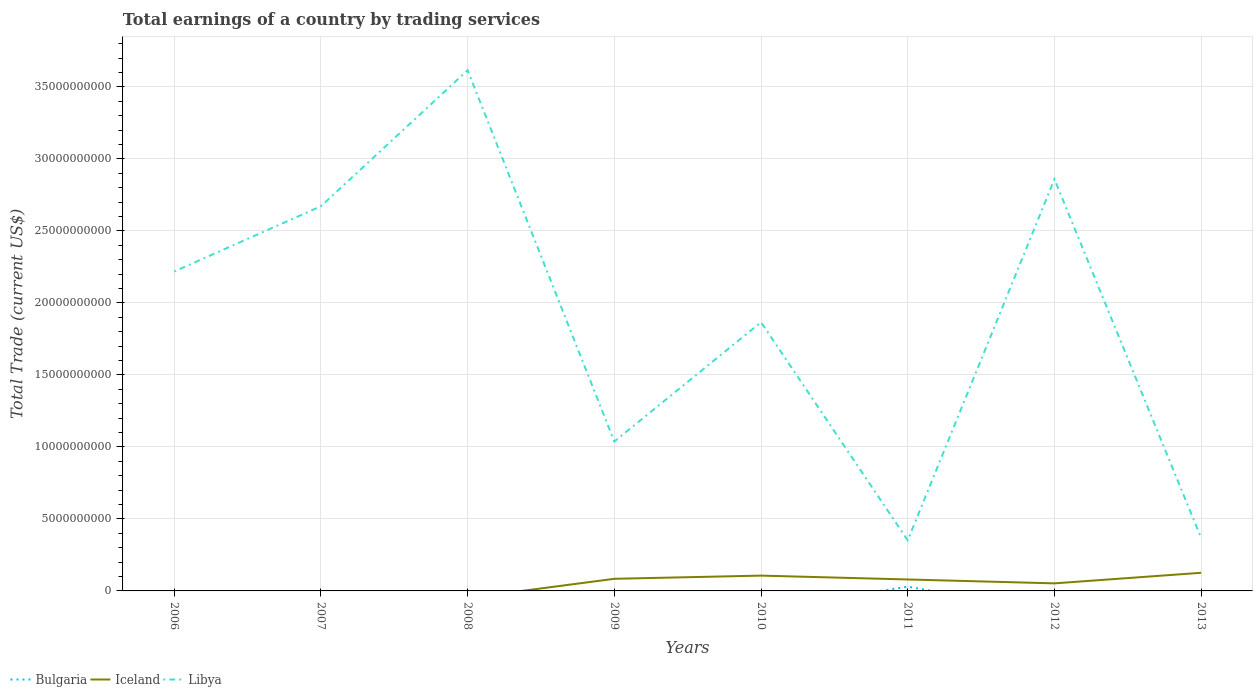How many different coloured lines are there?
Your answer should be compact. 3. What is the total total earnings in Iceland in the graph?
Provide a succinct answer. -7.34e+08. What is the difference between the highest and the second highest total earnings in Iceland?
Ensure brevity in your answer.  1.26e+09. What is the difference between the highest and the lowest total earnings in Iceland?
Your answer should be compact. 4. Is the total earnings in Libya strictly greater than the total earnings in Iceland over the years?
Offer a very short reply. No. How many lines are there?
Ensure brevity in your answer.  3. How many years are there in the graph?
Keep it short and to the point. 8. What is the difference between two consecutive major ticks on the Y-axis?
Provide a succinct answer. 5.00e+09. Are the values on the major ticks of Y-axis written in scientific E-notation?
Offer a terse response. No. How are the legend labels stacked?
Offer a very short reply. Horizontal. What is the title of the graph?
Provide a succinct answer. Total earnings of a country by trading services. What is the label or title of the Y-axis?
Provide a short and direct response. Total Trade (current US$). What is the Total Trade (current US$) in Iceland in 2006?
Provide a succinct answer. 0. What is the Total Trade (current US$) of Libya in 2006?
Offer a very short reply. 2.22e+1. What is the Total Trade (current US$) in Bulgaria in 2007?
Provide a short and direct response. 0. What is the Total Trade (current US$) of Iceland in 2007?
Keep it short and to the point. 0. What is the Total Trade (current US$) of Libya in 2007?
Give a very brief answer. 2.67e+1. What is the Total Trade (current US$) of Bulgaria in 2008?
Your answer should be compact. 0. What is the Total Trade (current US$) of Iceland in 2008?
Make the answer very short. 0. What is the Total Trade (current US$) of Libya in 2008?
Offer a very short reply. 3.62e+1. What is the Total Trade (current US$) in Iceland in 2009?
Keep it short and to the point. 8.42e+08. What is the Total Trade (current US$) of Libya in 2009?
Offer a terse response. 1.04e+1. What is the Total Trade (current US$) in Iceland in 2010?
Offer a terse response. 1.06e+09. What is the Total Trade (current US$) of Libya in 2010?
Your answer should be very brief. 1.87e+1. What is the Total Trade (current US$) of Bulgaria in 2011?
Your response must be concise. 2.94e+08. What is the Total Trade (current US$) in Iceland in 2011?
Keep it short and to the point. 7.95e+08. What is the Total Trade (current US$) in Libya in 2011?
Your answer should be compact. 3.51e+09. What is the Total Trade (current US$) in Iceland in 2012?
Offer a very short reply. 5.25e+08. What is the Total Trade (current US$) of Libya in 2012?
Keep it short and to the point. 2.86e+1. What is the Total Trade (current US$) in Bulgaria in 2013?
Offer a very short reply. 0. What is the Total Trade (current US$) in Iceland in 2013?
Make the answer very short. 1.26e+09. What is the Total Trade (current US$) in Libya in 2013?
Make the answer very short. 3.68e+09. Across all years, what is the maximum Total Trade (current US$) in Bulgaria?
Your answer should be very brief. 2.94e+08. Across all years, what is the maximum Total Trade (current US$) in Iceland?
Offer a very short reply. 1.26e+09. Across all years, what is the maximum Total Trade (current US$) in Libya?
Provide a succinct answer. 3.62e+1. Across all years, what is the minimum Total Trade (current US$) of Iceland?
Offer a terse response. 0. Across all years, what is the minimum Total Trade (current US$) of Libya?
Make the answer very short. 3.51e+09. What is the total Total Trade (current US$) of Bulgaria in the graph?
Ensure brevity in your answer.  2.94e+08. What is the total Total Trade (current US$) in Iceland in the graph?
Provide a succinct answer. 4.48e+09. What is the total Total Trade (current US$) of Libya in the graph?
Offer a terse response. 1.50e+11. What is the difference between the Total Trade (current US$) in Libya in 2006 and that in 2007?
Make the answer very short. -4.53e+09. What is the difference between the Total Trade (current US$) of Libya in 2006 and that in 2008?
Ensure brevity in your answer.  -1.40e+1. What is the difference between the Total Trade (current US$) of Libya in 2006 and that in 2009?
Keep it short and to the point. 1.18e+1. What is the difference between the Total Trade (current US$) of Libya in 2006 and that in 2010?
Provide a short and direct response. 3.52e+09. What is the difference between the Total Trade (current US$) in Libya in 2006 and that in 2011?
Offer a very short reply. 1.87e+1. What is the difference between the Total Trade (current US$) in Libya in 2006 and that in 2012?
Your answer should be compact. -6.41e+09. What is the difference between the Total Trade (current US$) in Libya in 2006 and that in 2013?
Provide a succinct answer. 1.85e+1. What is the difference between the Total Trade (current US$) in Libya in 2007 and that in 2008?
Your answer should be compact. -9.44e+09. What is the difference between the Total Trade (current US$) of Libya in 2007 and that in 2009?
Keep it short and to the point. 1.63e+1. What is the difference between the Total Trade (current US$) in Libya in 2007 and that in 2010?
Provide a succinct answer. 8.05e+09. What is the difference between the Total Trade (current US$) of Libya in 2007 and that in 2011?
Make the answer very short. 2.32e+1. What is the difference between the Total Trade (current US$) of Libya in 2007 and that in 2012?
Provide a short and direct response. -1.88e+09. What is the difference between the Total Trade (current US$) in Libya in 2007 and that in 2013?
Ensure brevity in your answer.  2.30e+1. What is the difference between the Total Trade (current US$) in Libya in 2008 and that in 2009?
Provide a succinct answer. 2.58e+1. What is the difference between the Total Trade (current US$) of Libya in 2008 and that in 2010?
Your answer should be very brief. 1.75e+1. What is the difference between the Total Trade (current US$) of Libya in 2008 and that in 2011?
Your response must be concise. 3.26e+1. What is the difference between the Total Trade (current US$) in Libya in 2008 and that in 2012?
Your answer should be compact. 7.56e+09. What is the difference between the Total Trade (current US$) of Libya in 2008 and that in 2013?
Keep it short and to the point. 3.25e+1. What is the difference between the Total Trade (current US$) in Iceland in 2009 and that in 2010?
Provide a short and direct response. -2.21e+08. What is the difference between the Total Trade (current US$) in Libya in 2009 and that in 2010?
Your answer should be compact. -8.28e+09. What is the difference between the Total Trade (current US$) of Iceland in 2009 and that in 2011?
Provide a short and direct response. 4.66e+07. What is the difference between the Total Trade (current US$) of Libya in 2009 and that in 2011?
Provide a short and direct response. 6.86e+09. What is the difference between the Total Trade (current US$) in Iceland in 2009 and that in 2012?
Offer a very short reply. 3.16e+08. What is the difference between the Total Trade (current US$) in Libya in 2009 and that in 2012?
Offer a terse response. -1.82e+1. What is the difference between the Total Trade (current US$) of Iceland in 2009 and that in 2013?
Keep it short and to the point. -4.17e+08. What is the difference between the Total Trade (current US$) in Libya in 2009 and that in 2013?
Your answer should be very brief. 6.70e+09. What is the difference between the Total Trade (current US$) in Iceland in 2010 and that in 2011?
Provide a succinct answer. 2.68e+08. What is the difference between the Total Trade (current US$) in Libya in 2010 and that in 2011?
Make the answer very short. 1.51e+1. What is the difference between the Total Trade (current US$) in Iceland in 2010 and that in 2012?
Make the answer very short. 5.38e+08. What is the difference between the Total Trade (current US$) of Libya in 2010 and that in 2012?
Offer a very short reply. -9.93e+09. What is the difference between the Total Trade (current US$) in Iceland in 2010 and that in 2013?
Ensure brevity in your answer.  -1.96e+08. What is the difference between the Total Trade (current US$) of Libya in 2010 and that in 2013?
Offer a very short reply. 1.50e+1. What is the difference between the Total Trade (current US$) in Iceland in 2011 and that in 2012?
Ensure brevity in your answer.  2.70e+08. What is the difference between the Total Trade (current US$) in Libya in 2011 and that in 2012?
Your answer should be very brief. -2.51e+1. What is the difference between the Total Trade (current US$) of Iceland in 2011 and that in 2013?
Provide a short and direct response. -4.64e+08. What is the difference between the Total Trade (current US$) of Libya in 2011 and that in 2013?
Your response must be concise. -1.63e+08. What is the difference between the Total Trade (current US$) in Iceland in 2012 and that in 2013?
Your response must be concise. -7.34e+08. What is the difference between the Total Trade (current US$) of Libya in 2012 and that in 2013?
Ensure brevity in your answer.  2.49e+1. What is the difference between the Total Trade (current US$) of Iceland in 2009 and the Total Trade (current US$) of Libya in 2010?
Give a very brief answer. -1.78e+1. What is the difference between the Total Trade (current US$) in Iceland in 2009 and the Total Trade (current US$) in Libya in 2011?
Provide a succinct answer. -2.67e+09. What is the difference between the Total Trade (current US$) of Iceland in 2009 and the Total Trade (current US$) of Libya in 2012?
Your answer should be compact. -2.78e+1. What is the difference between the Total Trade (current US$) in Iceland in 2009 and the Total Trade (current US$) in Libya in 2013?
Give a very brief answer. -2.84e+09. What is the difference between the Total Trade (current US$) of Iceland in 2010 and the Total Trade (current US$) of Libya in 2011?
Your response must be concise. -2.45e+09. What is the difference between the Total Trade (current US$) of Iceland in 2010 and the Total Trade (current US$) of Libya in 2012?
Keep it short and to the point. -2.75e+1. What is the difference between the Total Trade (current US$) in Iceland in 2010 and the Total Trade (current US$) in Libya in 2013?
Provide a succinct answer. -2.61e+09. What is the difference between the Total Trade (current US$) of Bulgaria in 2011 and the Total Trade (current US$) of Iceland in 2012?
Keep it short and to the point. -2.31e+08. What is the difference between the Total Trade (current US$) of Bulgaria in 2011 and the Total Trade (current US$) of Libya in 2012?
Your response must be concise. -2.83e+1. What is the difference between the Total Trade (current US$) of Iceland in 2011 and the Total Trade (current US$) of Libya in 2012?
Give a very brief answer. -2.78e+1. What is the difference between the Total Trade (current US$) of Bulgaria in 2011 and the Total Trade (current US$) of Iceland in 2013?
Your response must be concise. -9.65e+08. What is the difference between the Total Trade (current US$) in Bulgaria in 2011 and the Total Trade (current US$) in Libya in 2013?
Ensure brevity in your answer.  -3.38e+09. What is the difference between the Total Trade (current US$) of Iceland in 2011 and the Total Trade (current US$) of Libya in 2013?
Ensure brevity in your answer.  -2.88e+09. What is the difference between the Total Trade (current US$) of Iceland in 2012 and the Total Trade (current US$) of Libya in 2013?
Your answer should be very brief. -3.15e+09. What is the average Total Trade (current US$) of Bulgaria per year?
Offer a terse response. 3.67e+07. What is the average Total Trade (current US$) of Iceland per year?
Your answer should be compact. 5.61e+08. What is the average Total Trade (current US$) in Libya per year?
Your response must be concise. 1.87e+1. In the year 2009, what is the difference between the Total Trade (current US$) of Iceland and Total Trade (current US$) of Libya?
Offer a very short reply. -9.53e+09. In the year 2010, what is the difference between the Total Trade (current US$) of Iceland and Total Trade (current US$) of Libya?
Your response must be concise. -1.76e+1. In the year 2011, what is the difference between the Total Trade (current US$) in Bulgaria and Total Trade (current US$) in Iceland?
Give a very brief answer. -5.01e+08. In the year 2011, what is the difference between the Total Trade (current US$) in Bulgaria and Total Trade (current US$) in Libya?
Provide a short and direct response. -3.22e+09. In the year 2011, what is the difference between the Total Trade (current US$) of Iceland and Total Trade (current US$) of Libya?
Make the answer very short. -2.72e+09. In the year 2012, what is the difference between the Total Trade (current US$) of Iceland and Total Trade (current US$) of Libya?
Make the answer very short. -2.81e+1. In the year 2013, what is the difference between the Total Trade (current US$) of Iceland and Total Trade (current US$) of Libya?
Offer a terse response. -2.42e+09. What is the ratio of the Total Trade (current US$) in Libya in 2006 to that in 2007?
Your response must be concise. 0.83. What is the ratio of the Total Trade (current US$) of Libya in 2006 to that in 2008?
Provide a short and direct response. 0.61. What is the ratio of the Total Trade (current US$) in Libya in 2006 to that in 2009?
Your answer should be compact. 2.14. What is the ratio of the Total Trade (current US$) in Libya in 2006 to that in 2010?
Offer a very short reply. 1.19. What is the ratio of the Total Trade (current US$) of Libya in 2006 to that in 2011?
Ensure brevity in your answer.  6.31. What is the ratio of the Total Trade (current US$) of Libya in 2006 to that in 2012?
Make the answer very short. 0.78. What is the ratio of the Total Trade (current US$) of Libya in 2006 to that in 2013?
Give a very brief answer. 6.03. What is the ratio of the Total Trade (current US$) of Libya in 2007 to that in 2008?
Provide a succinct answer. 0.74. What is the ratio of the Total Trade (current US$) of Libya in 2007 to that in 2009?
Offer a terse response. 2.57. What is the ratio of the Total Trade (current US$) in Libya in 2007 to that in 2010?
Your answer should be compact. 1.43. What is the ratio of the Total Trade (current US$) of Libya in 2007 to that in 2011?
Your response must be concise. 7.6. What is the ratio of the Total Trade (current US$) of Libya in 2007 to that in 2012?
Ensure brevity in your answer.  0.93. What is the ratio of the Total Trade (current US$) of Libya in 2007 to that in 2013?
Your response must be concise. 7.26. What is the ratio of the Total Trade (current US$) of Libya in 2008 to that in 2009?
Give a very brief answer. 3.48. What is the ratio of the Total Trade (current US$) in Libya in 2008 to that in 2010?
Make the answer very short. 1.94. What is the ratio of the Total Trade (current US$) in Libya in 2008 to that in 2011?
Offer a terse response. 10.29. What is the ratio of the Total Trade (current US$) of Libya in 2008 to that in 2012?
Give a very brief answer. 1.26. What is the ratio of the Total Trade (current US$) of Libya in 2008 to that in 2013?
Keep it short and to the point. 9.83. What is the ratio of the Total Trade (current US$) of Iceland in 2009 to that in 2010?
Give a very brief answer. 0.79. What is the ratio of the Total Trade (current US$) of Libya in 2009 to that in 2010?
Provide a short and direct response. 0.56. What is the ratio of the Total Trade (current US$) of Iceland in 2009 to that in 2011?
Keep it short and to the point. 1.06. What is the ratio of the Total Trade (current US$) in Libya in 2009 to that in 2011?
Provide a short and direct response. 2.95. What is the ratio of the Total Trade (current US$) of Iceland in 2009 to that in 2012?
Make the answer very short. 1.6. What is the ratio of the Total Trade (current US$) of Libya in 2009 to that in 2012?
Provide a succinct answer. 0.36. What is the ratio of the Total Trade (current US$) of Iceland in 2009 to that in 2013?
Ensure brevity in your answer.  0.67. What is the ratio of the Total Trade (current US$) in Libya in 2009 to that in 2013?
Ensure brevity in your answer.  2.82. What is the ratio of the Total Trade (current US$) of Iceland in 2010 to that in 2011?
Offer a very short reply. 1.34. What is the ratio of the Total Trade (current US$) of Libya in 2010 to that in 2011?
Offer a very short reply. 5.31. What is the ratio of the Total Trade (current US$) in Iceland in 2010 to that in 2012?
Give a very brief answer. 2.02. What is the ratio of the Total Trade (current US$) in Libya in 2010 to that in 2012?
Your answer should be very brief. 0.65. What is the ratio of the Total Trade (current US$) in Iceland in 2010 to that in 2013?
Your answer should be very brief. 0.84. What is the ratio of the Total Trade (current US$) in Libya in 2010 to that in 2013?
Provide a short and direct response. 5.07. What is the ratio of the Total Trade (current US$) of Iceland in 2011 to that in 2012?
Give a very brief answer. 1.51. What is the ratio of the Total Trade (current US$) in Libya in 2011 to that in 2012?
Ensure brevity in your answer.  0.12. What is the ratio of the Total Trade (current US$) of Iceland in 2011 to that in 2013?
Your answer should be very brief. 0.63. What is the ratio of the Total Trade (current US$) of Libya in 2011 to that in 2013?
Offer a very short reply. 0.96. What is the ratio of the Total Trade (current US$) of Iceland in 2012 to that in 2013?
Give a very brief answer. 0.42. What is the ratio of the Total Trade (current US$) of Libya in 2012 to that in 2013?
Provide a short and direct response. 7.78. What is the difference between the highest and the second highest Total Trade (current US$) in Iceland?
Offer a terse response. 1.96e+08. What is the difference between the highest and the second highest Total Trade (current US$) in Libya?
Ensure brevity in your answer.  7.56e+09. What is the difference between the highest and the lowest Total Trade (current US$) of Bulgaria?
Ensure brevity in your answer.  2.94e+08. What is the difference between the highest and the lowest Total Trade (current US$) of Iceland?
Keep it short and to the point. 1.26e+09. What is the difference between the highest and the lowest Total Trade (current US$) in Libya?
Make the answer very short. 3.26e+1. 